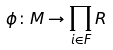<formula> <loc_0><loc_0><loc_500><loc_500>\phi \colon M \rightarrow \prod _ { i \in F } R</formula> 